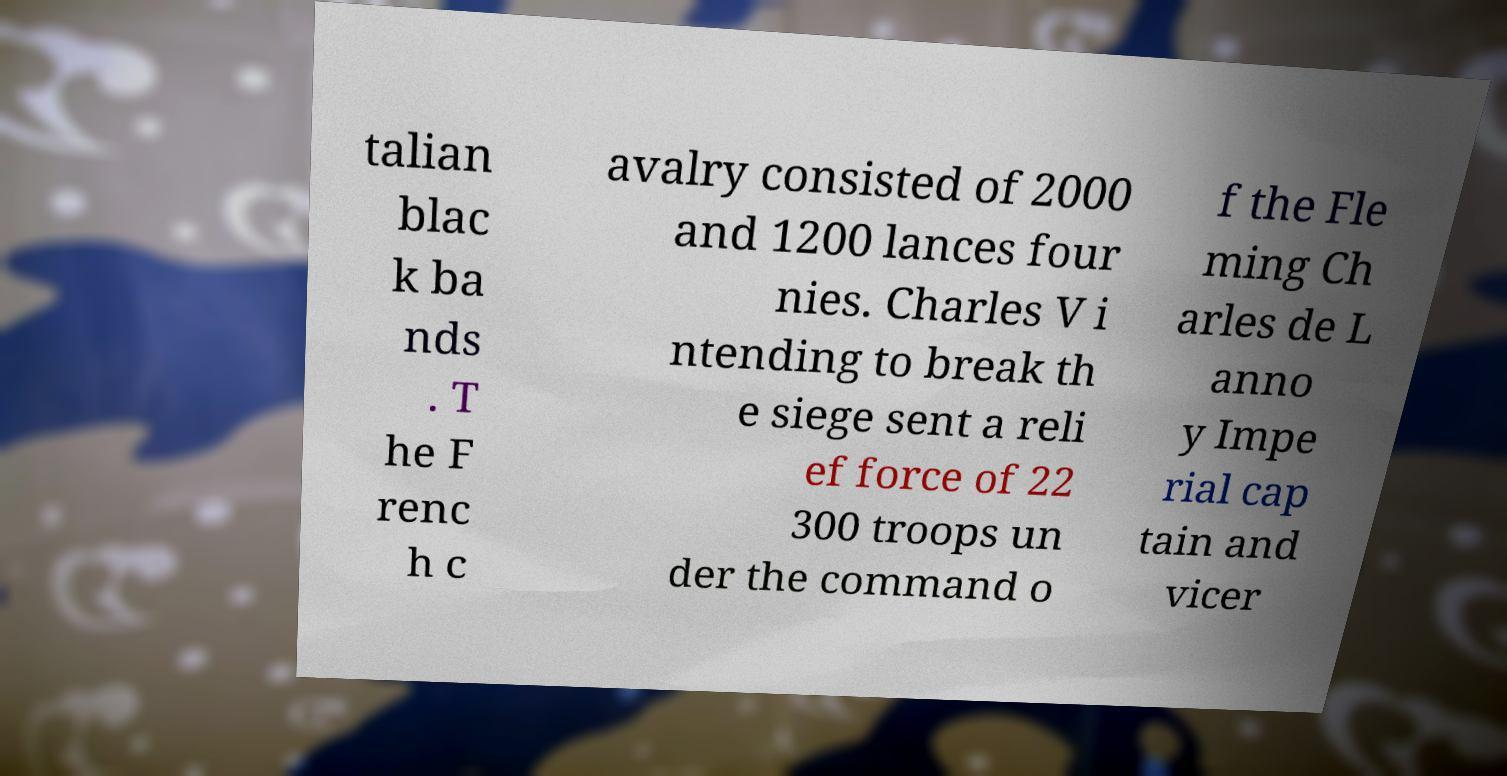I need the written content from this picture converted into text. Can you do that? talian blac k ba nds . T he F renc h c avalry consisted of 2000 and 1200 lances four nies. Charles V i ntending to break th e siege sent a reli ef force of 22 300 troops un der the command o f the Fle ming Ch arles de L anno y Impe rial cap tain and vicer 